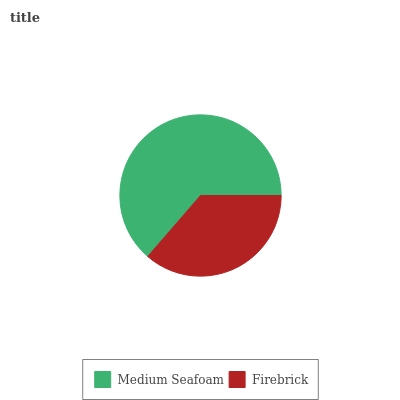Is Firebrick the minimum?
Answer yes or no. Yes. Is Medium Seafoam the maximum?
Answer yes or no. Yes. Is Firebrick the maximum?
Answer yes or no. No. Is Medium Seafoam greater than Firebrick?
Answer yes or no. Yes. Is Firebrick less than Medium Seafoam?
Answer yes or no. Yes. Is Firebrick greater than Medium Seafoam?
Answer yes or no. No. Is Medium Seafoam less than Firebrick?
Answer yes or no. No. Is Medium Seafoam the high median?
Answer yes or no. Yes. Is Firebrick the low median?
Answer yes or no. Yes. Is Firebrick the high median?
Answer yes or no. No. Is Medium Seafoam the low median?
Answer yes or no. No. 